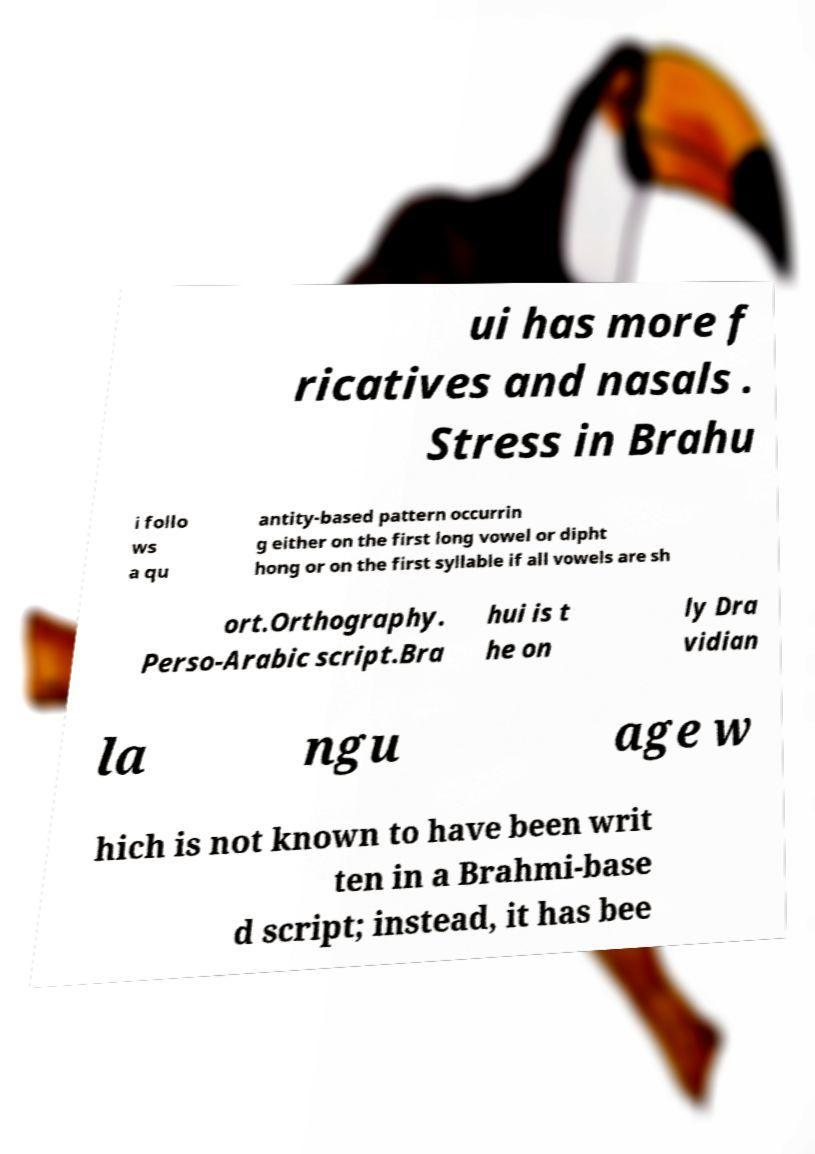Can you accurately transcribe the text from the provided image for me? ui has more f ricatives and nasals . Stress in Brahu i follo ws a qu antity-based pattern occurrin g either on the first long vowel or dipht hong or on the first syllable if all vowels are sh ort.Orthography. Perso-Arabic script.Bra hui is t he on ly Dra vidian la ngu age w hich is not known to have been writ ten in a Brahmi-base d script; instead, it has bee 